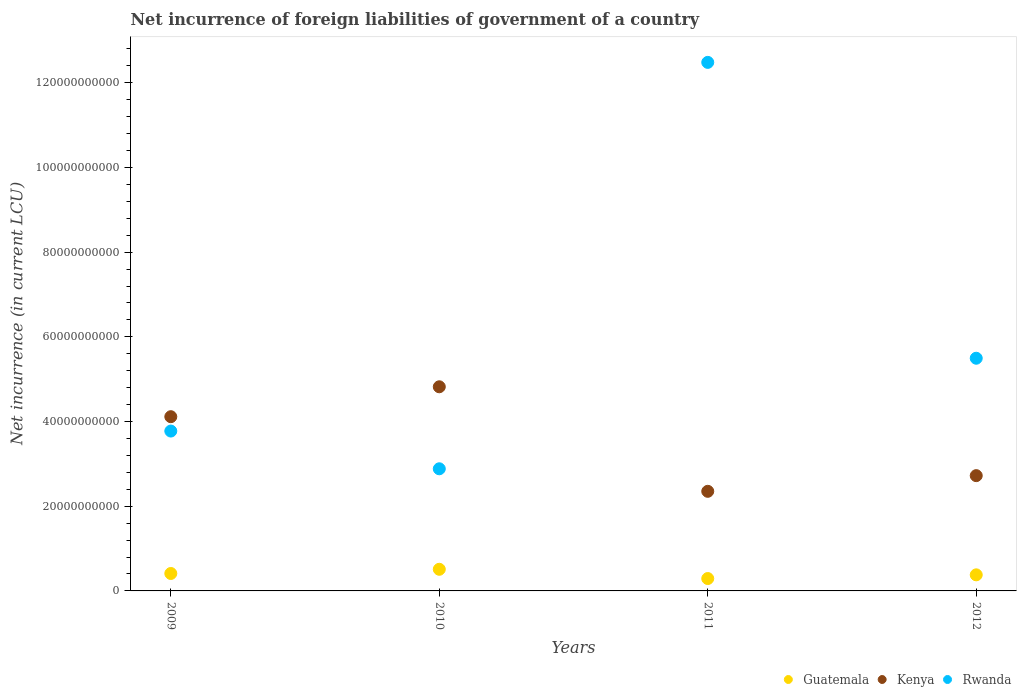Is the number of dotlines equal to the number of legend labels?
Offer a very short reply. Yes. What is the net incurrence of foreign liabilities in Rwanda in 2012?
Your answer should be compact. 5.49e+1. Across all years, what is the maximum net incurrence of foreign liabilities in Guatemala?
Your answer should be compact. 5.11e+09. Across all years, what is the minimum net incurrence of foreign liabilities in Rwanda?
Offer a very short reply. 2.88e+1. What is the total net incurrence of foreign liabilities in Rwanda in the graph?
Your answer should be very brief. 2.46e+11. What is the difference between the net incurrence of foreign liabilities in Kenya in 2011 and that in 2012?
Make the answer very short. -3.70e+09. What is the difference between the net incurrence of foreign liabilities in Rwanda in 2011 and the net incurrence of foreign liabilities in Kenya in 2012?
Your answer should be very brief. 9.76e+1. What is the average net incurrence of foreign liabilities in Guatemala per year?
Your response must be concise. 3.99e+09. In the year 2010, what is the difference between the net incurrence of foreign liabilities in Rwanda and net incurrence of foreign liabilities in Guatemala?
Offer a terse response. 2.37e+1. What is the ratio of the net incurrence of foreign liabilities in Kenya in 2009 to that in 2011?
Offer a very short reply. 1.75. What is the difference between the highest and the second highest net incurrence of foreign liabilities in Rwanda?
Offer a terse response. 6.99e+1. What is the difference between the highest and the lowest net incurrence of foreign liabilities in Kenya?
Make the answer very short. 2.47e+1. Is the net incurrence of foreign liabilities in Guatemala strictly less than the net incurrence of foreign liabilities in Rwanda over the years?
Provide a short and direct response. Yes. How many dotlines are there?
Ensure brevity in your answer.  3. How many years are there in the graph?
Your answer should be very brief. 4. Does the graph contain any zero values?
Your response must be concise. No. What is the title of the graph?
Provide a succinct answer. Net incurrence of foreign liabilities of government of a country. Does "Austria" appear as one of the legend labels in the graph?
Offer a terse response. No. What is the label or title of the Y-axis?
Make the answer very short. Net incurrence (in current LCU). What is the Net incurrence (in current LCU) in Guatemala in 2009?
Make the answer very short. 4.12e+09. What is the Net incurrence (in current LCU) in Kenya in 2009?
Offer a very short reply. 4.11e+1. What is the Net incurrence (in current LCU) in Rwanda in 2009?
Your answer should be very brief. 3.78e+1. What is the Net incurrence (in current LCU) in Guatemala in 2010?
Give a very brief answer. 5.11e+09. What is the Net incurrence (in current LCU) of Kenya in 2010?
Your response must be concise. 4.82e+1. What is the Net incurrence (in current LCU) in Rwanda in 2010?
Offer a very short reply. 2.88e+1. What is the Net incurrence (in current LCU) in Guatemala in 2011?
Make the answer very short. 2.92e+09. What is the Net incurrence (in current LCU) of Kenya in 2011?
Offer a very short reply. 2.35e+1. What is the Net incurrence (in current LCU) of Rwanda in 2011?
Make the answer very short. 1.25e+11. What is the Net incurrence (in current LCU) of Guatemala in 2012?
Ensure brevity in your answer.  3.80e+09. What is the Net incurrence (in current LCU) in Kenya in 2012?
Your answer should be very brief. 2.72e+1. What is the Net incurrence (in current LCU) in Rwanda in 2012?
Provide a short and direct response. 5.49e+1. Across all years, what is the maximum Net incurrence (in current LCU) of Guatemala?
Provide a succinct answer. 5.11e+09. Across all years, what is the maximum Net incurrence (in current LCU) in Kenya?
Your answer should be very brief. 4.82e+1. Across all years, what is the maximum Net incurrence (in current LCU) in Rwanda?
Ensure brevity in your answer.  1.25e+11. Across all years, what is the minimum Net incurrence (in current LCU) in Guatemala?
Provide a short and direct response. 2.92e+09. Across all years, what is the minimum Net incurrence (in current LCU) of Kenya?
Provide a short and direct response. 2.35e+1. Across all years, what is the minimum Net incurrence (in current LCU) of Rwanda?
Offer a very short reply. 2.88e+1. What is the total Net incurrence (in current LCU) in Guatemala in the graph?
Provide a succinct answer. 1.59e+1. What is the total Net incurrence (in current LCU) in Kenya in the graph?
Give a very brief answer. 1.40e+11. What is the total Net incurrence (in current LCU) in Rwanda in the graph?
Give a very brief answer. 2.46e+11. What is the difference between the Net incurrence (in current LCU) in Guatemala in 2009 and that in 2010?
Your answer should be compact. -9.92e+08. What is the difference between the Net incurrence (in current LCU) of Kenya in 2009 and that in 2010?
Provide a succinct answer. -7.06e+09. What is the difference between the Net incurrence (in current LCU) in Rwanda in 2009 and that in 2010?
Keep it short and to the point. 8.91e+09. What is the difference between the Net incurrence (in current LCU) in Guatemala in 2009 and that in 2011?
Provide a succinct answer. 1.19e+09. What is the difference between the Net incurrence (in current LCU) of Kenya in 2009 and that in 2011?
Your answer should be compact. 1.76e+1. What is the difference between the Net incurrence (in current LCU) of Rwanda in 2009 and that in 2011?
Your answer should be compact. -8.71e+1. What is the difference between the Net incurrence (in current LCU) of Guatemala in 2009 and that in 2012?
Provide a succinct answer. 3.20e+08. What is the difference between the Net incurrence (in current LCU) in Kenya in 2009 and that in 2012?
Provide a succinct answer. 1.39e+1. What is the difference between the Net incurrence (in current LCU) in Rwanda in 2009 and that in 2012?
Provide a succinct answer. -1.72e+1. What is the difference between the Net incurrence (in current LCU) of Guatemala in 2010 and that in 2011?
Your answer should be very brief. 2.19e+09. What is the difference between the Net incurrence (in current LCU) in Kenya in 2010 and that in 2011?
Your answer should be very brief. 2.47e+1. What is the difference between the Net incurrence (in current LCU) of Rwanda in 2010 and that in 2011?
Ensure brevity in your answer.  -9.60e+1. What is the difference between the Net incurrence (in current LCU) of Guatemala in 2010 and that in 2012?
Your answer should be very brief. 1.31e+09. What is the difference between the Net incurrence (in current LCU) of Kenya in 2010 and that in 2012?
Keep it short and to the point. 2.10e+1. What is the difference between the Net incurrence (in current LCU) of Rwanda in 2010 and that in 2012?
Provide a succinct answer. -2.61e+1. What is the difference between the Net incurrence (in current LCU) of Guatemala in 2011 and that in 2012?
Give a very brief answer. -8.74e+08. What is the difference between the Net incurrence (in current LCU) in Kenya in 2011 and that in 2012?
Your answer should be compact. -3.70e+09. What is the difference between the Net incurrence (in current LCU) in Rwanda in 2011 and that in 2012?
Ensure brevity in your answer.  6.99e+1. What is the difference between the Net incurrence (in current LCU) of Guatemala in 2009 and the Net incurrence (in current LCU) of Kenya in 2010?
Provide a succinct answer. -4.41e+1. What is the difference between the Net incurrence (in current LCU) in Guatemala in 2009 and the Net incurrence (in current LCU) in Rwanda in 2010?
Offer a terse response. -2.47e+1. What is the difference between the Net incurrence (in current LCU) in Kenya in 2009 and the Net incurrence (in current LCU) in Rwanda in 2010?
Keep it short and to the point. 1.23e+1. What is the difference between the Net incurrence (in current LCU) in Guatemala in 2009 and the Net incurrence (in current LCU) in Kenya in 2011?
Provide a short and direct response. -1.94e+1. What is the difference between the Net incurrence (in current LCU) of Guatemala in 2009 and the Net incurrence (in current LCU) of Rwanda in 2011?
Offer a very short reply. -1.21e+11. What is the difference between the Net incurrence (in current LCU) in Kenya in 2009 and the Net incurrence (in current LCU) in Rwanda in 2011?
Offer a terse response. -8.37e+1. What is the difference between the Net incurrence (in current LCU) in Guatemala in 2009 and the Net incurrence (in current LCU) in Kenya in 2012?
Offer a very short reply. -2.31e+1. What is the difference between the Net incurrence (in current LCU) in Guatemala in 2009 and the Net incurrence (in current LCU) in Rwanda in 2012?
Provide a succinct answer. -5.08e+1. What is the difference between the Net incurrence (in current LCU) of Kenya in 2009 and the Net incurrence (in current LCU) of Rwanda in 2012?
Your answer should be compact. -1.38e+1. What is the difference between the Net incurrence (in current LCU) in Guatemala in 2010 and the Net incurrence (in current LCU) in Kenya in 2011?
Your answer should be compact. -1.84e+1. What is the difference between the Net incurrence (in current LCU) in Guatemala in 2010 and the Net incurrence (in current LCU) in Rwanda in 2011?
Offer a very short reply. -1.20e+11. What is the difference between the Net incurrence (in current LCU) in Kenya in 2010 and the Net incurrence (in current LCU) in Rwanda in 2011?
Provide a short and direct response. -7.66e+1. What is the difference between the Net incurrence (in current LCU) of Guatemala in 2010 and the Net incurrence (in current LCU) of Kenya in 2012?
Provide a succinct answer. -2.21e+1. What is the difference between the Net incurrence (in current LCU) of Guatemala in 2010 and the Net incurrence (in current LCU) of Rwanda in 2012?
Offer a very short reply. -4.98e+1. What is the difference between the Net incurrence (in current LCU) in Kenya in 2010 and the Net incurrence (in current LCU) in Rwanda in 2012?
Your answer should be compact. -6.74e+09. What is the difference between the Net incurrence (in current LCU) in Guatemala in 2011 and the Net incurrence (in current LCU) in Kenya in 2012?
Make the answer very short. -2.43e+1. What is the difference between the Net incurrence (in current LCU) in Guatemala in 2011 and the Net incurrence (in current LCU) in Rwanda in 2012?
Ensure brevity in your answer.  -5.20e+1. What is the difference between the Net incurrence (in current LCU) of Kenya in 2011 and the Net incurrence (in current LCU) of Rwanda in 2012?
Keep it short and to the point. -3.14e+1. What is the average Net incurrence (in current LCU) of Guatemala per year?
Keep it short and to the point. 3.99e+09. What is the average Net incurrence (in current LCU) of Kenya per year?
Your answer should be compact. 3.50e+1. What is the average Net incurrence (in current LCU) in Rwanda per year?
Offer a very short reply. 6.16e+1. In the year 2009, what is the difference between the Net incurrence (in current LCU) of Guatemala and Net incurrence (in current LCU) of Kenya?
Your answer should be compact. -3.70e+1. In the year 2009, what is the difference between the Net incurrence (in current LCU) in Guatemala and Net incurrence (in current LCU) in Rwanda?
Make the answer very short. -3.36e+1. In the year 2009, what is the difference between the Net incurrence (in current LCU) in Kenya and Net incurrence (in current LCU) in Rwanda?
Your answer should be compact. 3.39e+09. In the year 2010, what is the difference between the Net incurrence (in current LCU) of Guatemala and Net incurrence (in current LCU) of Kenya?
Give a very brief answer. -4.31e+1. In the year 2010, what is the difference between the Net incurrence (in current LCU) in Guatemala and Net incurrence (in current LCU) in Rwanda?
Give a very brief answer. -2.37e+1. In the year 2010, what is the difference between the Net incurrence (in current LCU) of Kenya and Net incurrence (in current LCU) of Rwanda?
Your response must be concise. 1.94e+1. In the year 2011, what is the difference between the Net incurrence (in current LCU) in Guatemala and Net incurrence (in current LCU) in Kenya?
Keep it short and to the point. -2.06e+1. In the year 2011, what is the difference between the Net incurrence (in current LCU) of Guatemala and Net incurrence (in current LCU) of Rwanda?
Your answer should be very brief. -1.22e+11. In the year 2011, what is the difference between the Net incurrence (in current LCU) in Kenya and Net incurrence (in current LCU) in Rwanda?
Give a very brief answer. -1.01e+11. In the year 2012, what is the difference between the Net incurrence (in current LCU) of Guatemala and Net incurrence (in current LCU) of Kenya?
Provide a succinct answer. -2.34e+1. In the year 2012, what is the difference between the Net incurrence (in current LCU) in Guatemala and Net incurrence (in current LCU) in Rwanda?
Make the answer very short. -5.12e+1. In the year 2012, what is the difference between the Net incurrence (in current LCU) of Kenya and Net incurrence (in current LCU) of Rwanda?
Provide a succinct answer. -2.77e+1. What is the ratio of the Net incurrence (in current LCU) in Guatemala in 2009 to that in 2010?
Provide a short and direct response. 0.81. What is the ratio of the Net incurrence (in current LCU) in Kenya in 2009 to that in 2010?
Provide a short and direct response. 0.85. What is the ratio of the Net incurrence (in current LCU) in Rwanda in 2009 to that in 2010?
Your answer should be very brief. 1.31. What is the ratio of the Net incurrence (in current LCU) of Guatemala in 2009 to that in 2011?
Make the answer very short. 1.41. What is the ratio of the Net incurrence (in current LCU) in Kenya in 2009 to that in 2011?
Offer a very short reply. 1.75. What is the ratio of the Net incurrence (in current LCU) in Rwanda in 2009 to that in 2011?
Your answer should be very brief. 0.3. What is the ratio of the Net incurrence (in current LCU) in Guatemala in 2009 to that in 2012?
Provide a short and direct response. 1.08. What is the ratio of the Net incurrence (in current LCU) in Kenya in 2009 to that in 2012?
Your answer should be very brief. 1.51. What is the ratio of the Net incurrence (in current LCU) of Rwanda in 2009 to that in 2012?
Your response must be concise. 0.69. What is the ratio of the Net incurrence (in current LCU) in Guatemala in 2010 to that in 2011?
Give a very brief answer. 1.75. What is the ratio of the Net incurrence (in current LCU) in Kenya in 2010 to that in 2011?
Offer a very short reply. 2.05. What is the ratio of the Net incurrence (in current LCU) of Rwanda in 2010 to that in 2011?
Offer a very short reply. 0.23. What is the ratio of the Net incurrence (in current LCU) in Guatemala in 2010 to that in 2012?
Provide a succinct answer. 1.35. What is the ratio of the Net incurrence (in current LCU) of Kenya in 2010 to that in 2012?
Ensure brevity in your answer.  1.77. What is the ratio of the Net incurrence (in current LCU) of Rwanda in 2010 to that in 2012?
Make the answer very short. 0.52. What is the ratio of the Net incurrence (in current LCU) of Guatemala in 2011 to that in 2012?
Offer a terse response. 0.77. What is the ratio of the Net incurrence (in current LCU) in Kenya in 2011 to that in 2012?
Keep it short and to the point. 0.86. What is the ratio of the Net incurrence (in current LCU) of Rwanda in 2011 to that in 2012?
Keep it short and to the point. 2.27. What is the difference between the highest and the second highest Net incurrence (in current LCU) in Guatemala?
Your response must be concise. 9.92e+08. What is the difference between the highest and the second highest Net incurrence (in current LCU) in Kenya?
Your answer should be very brief. 7.06e+09. What is the difference between the highest and the second highest Net incurrence (in current LCU) of Rwanda?
Ensure brevity in your answer.  6.99e+1. What is the difference between the highest and the lowest Net incurrence (in current LCU) in Guatemala?
Give a very brief answer. 2.19e+09. What is the difference between the highest and the lowest Net incurrence (in current LCU) in Kenya?
Your response must be concise. 2.47e+1. What is the difference between the highest and the lowest Net incurrence (in current LCU) in Rwanda?
Provide a short and direct response. 9.60e+1. 